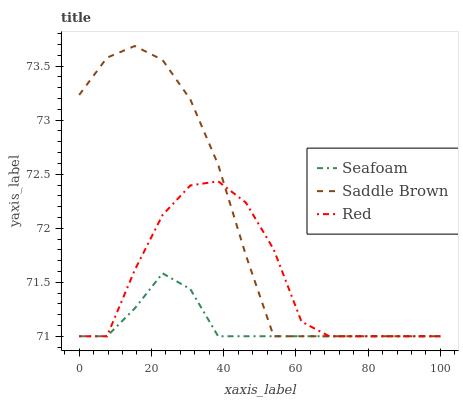Does Seafoam have the minimum area under the curve?
Answer yes or no. Yes. Does Saddle Brown have the maximum area under the curve?
Answer yes or no. Yes. Does Red have the minimum area under the curve?
Answer yes or no. No. Does Red have the maximum area under the curve?
Answer yes or no. No. Is Seafoam the smoothest?
Answer yes or no. Yes. Is Red the roughest?
Answer yes or no. Yes. Is Saddle Brown the smoothest?
Answer yes or no. No. Is Saddle Brown the roughest?
Answer yes or no. No. Does Seafoam have the lowest value?
Answer yes or no. Yes. Does Saddle Brown have the highest value?
Answer yes or no. Yes. Does Red have the highest value?
Answer yes or no. No. Does Saddle Brown intersect Red?
Answer yes or no. Yes. Is Saddle Brown less than Red?
Answer yes or no. No. Is Saddle Brown greater than Red?
Answer yes or no. No. 